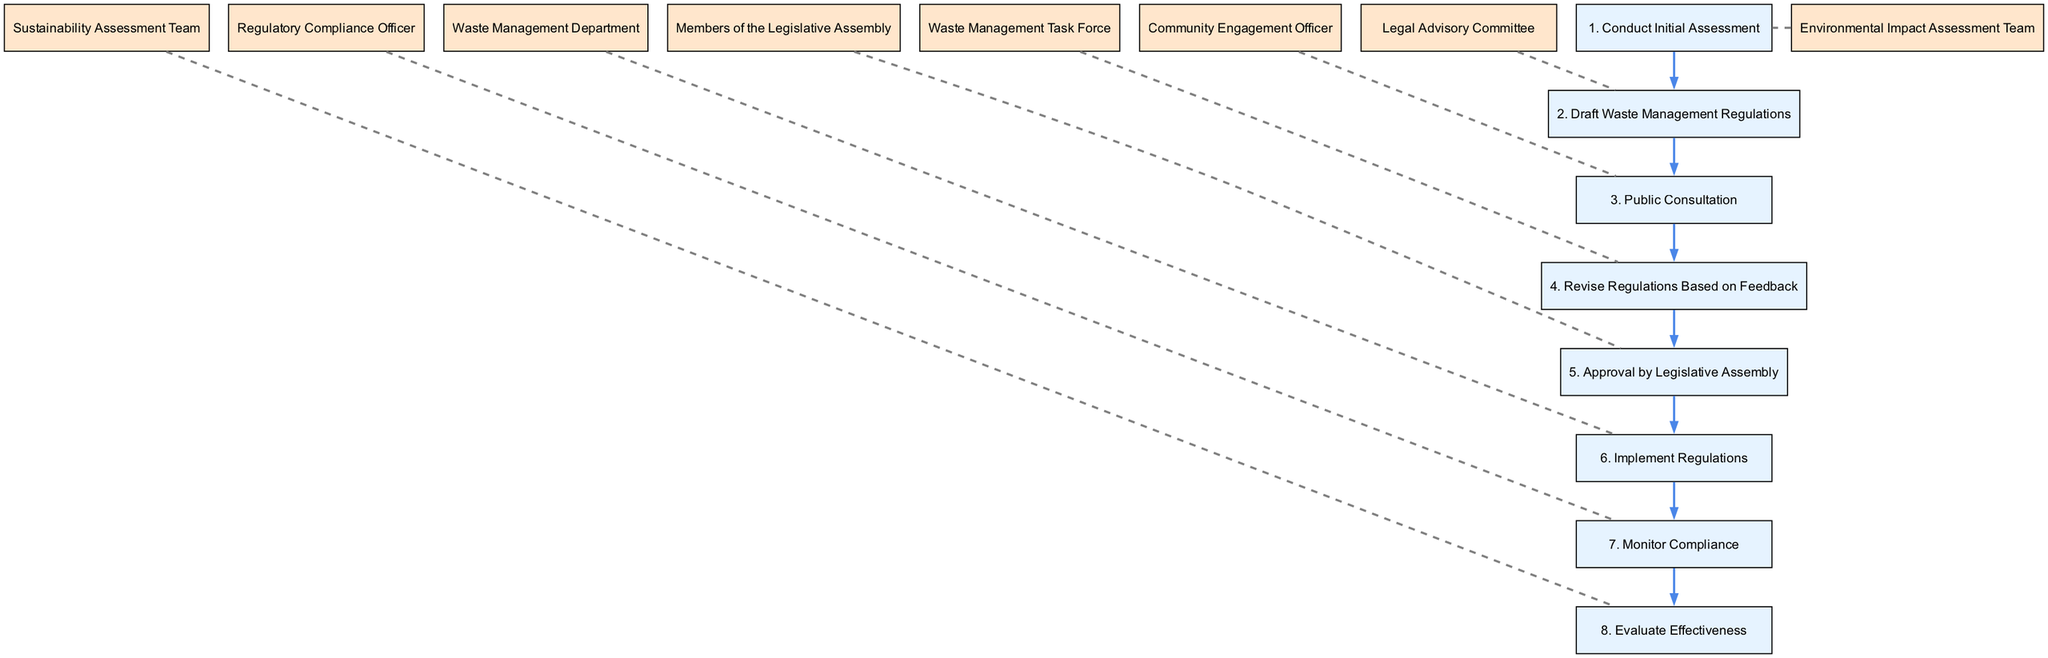What is the first step in implementing the waste management regulations? The first step listed in the diagram is "Conduct Initial Assessment," which is the action taken by the Environmental Impact Assessment Team.
Answer: Conduct Initial Assessment Which entity is responsible for drafting the waste management regulations? According to the diagram, the entity responsible for drafting the waste management regulations is the Legal Advisory Committee.
Answer: Legal Advisory Committee How many steps are there in total for implementing the waste management regulations? Counting the steps from 1 to 8 in the diagram, there are a total of 8 steps in the process.
Answer: 8 Who approves the waste management regulations? The diagram indicates that the Members of the Legislative Assembly are responsible for approving the waste management regulations.
Answer: Members of the Legislative Assembly What action follows the public consultation step? The diagram shows that the step following the public consultation is "Revise Regulations Based on Feedback," undertaken by the Waste Management Task Force.
Answer: Revise Regulations Based on Feedback What is the last action in the waste management regulations implementation sequence? The last action indicated in the diagram is "Evaluate Effectiveness," which is performed by the Sustainability Assessment Team.
Answer: Evaluate Effectiveness Which step comes after the approval by the Legislative Assembly? Referring to the diagram, after the approval by the Legislative Assembly, the next step is "Implement Regulations," conducted by the Waste Management Department.
Answer: Implement Regulations What is the primary role of the Regulatory Compliance Officer in the sequence? The diagram highlights that the primary role of the Regulatory Compliance Officer is to "Monitor Compliance."
Answer: Monitor Compliance Which step involves community participation? In the sequence listed in the diagram, the step that involves community participation is "Public Consultation," led by the Community Engagement Officer.
Answer: Public Consultation 